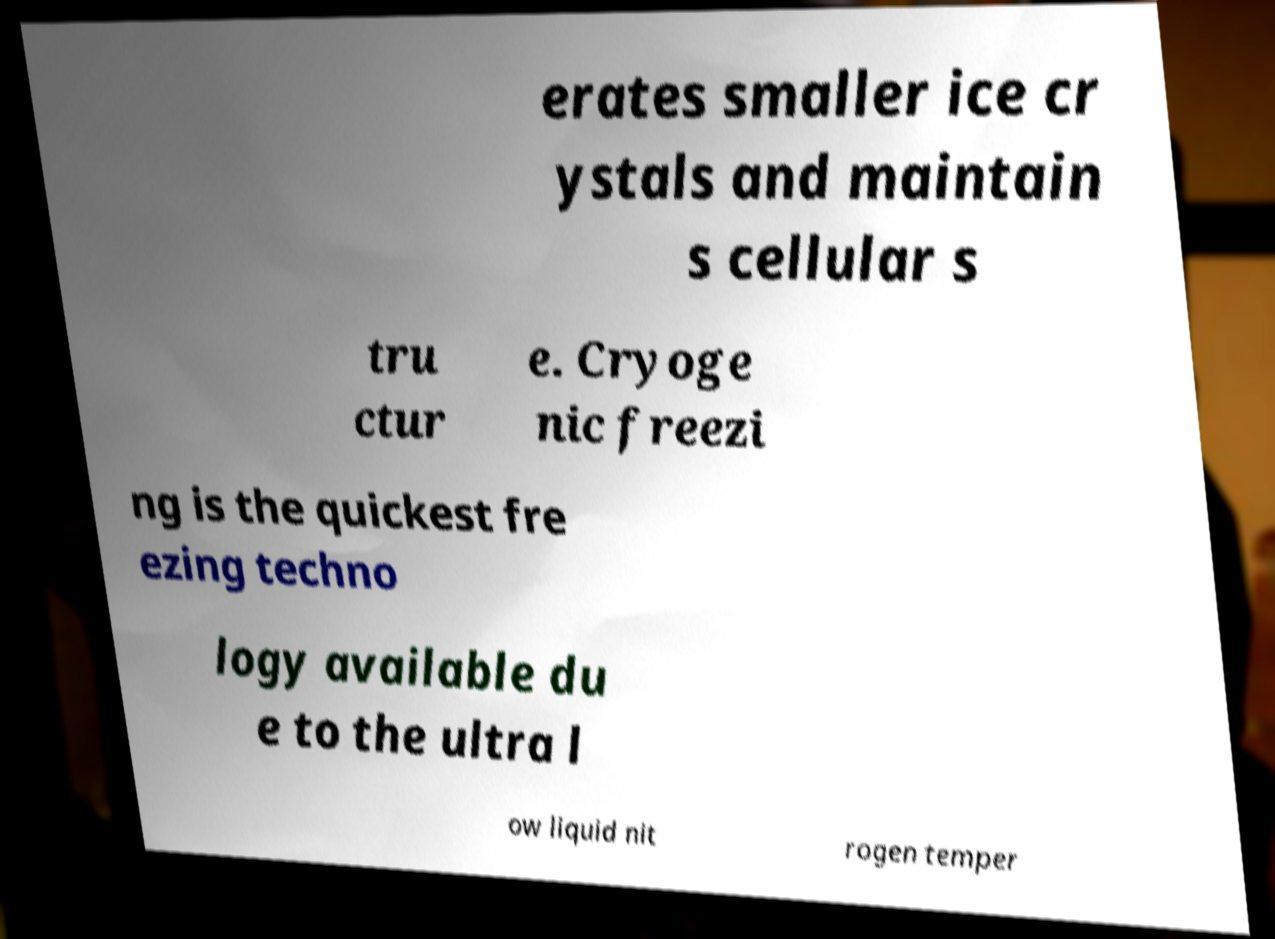Could you extract and type out the text from this image? erates smaller ice cr ystals and maintain s cellular s tru ctur e. Cryoge nic freezi ng is the quickest fre ezing techno logy available du e to the ultra l ow liquid nit rogen temper 